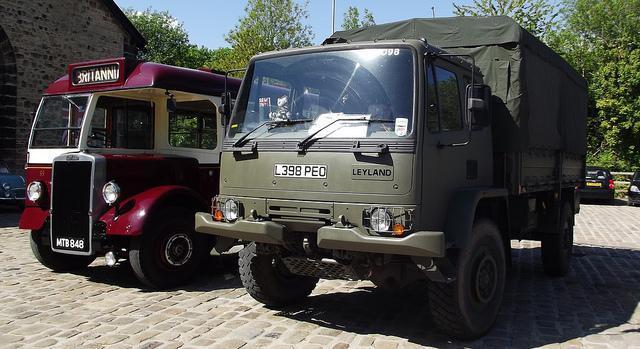Is the given caption "The truck is next to the bus." fitting for the image?
Answer yes or no. Yes. 